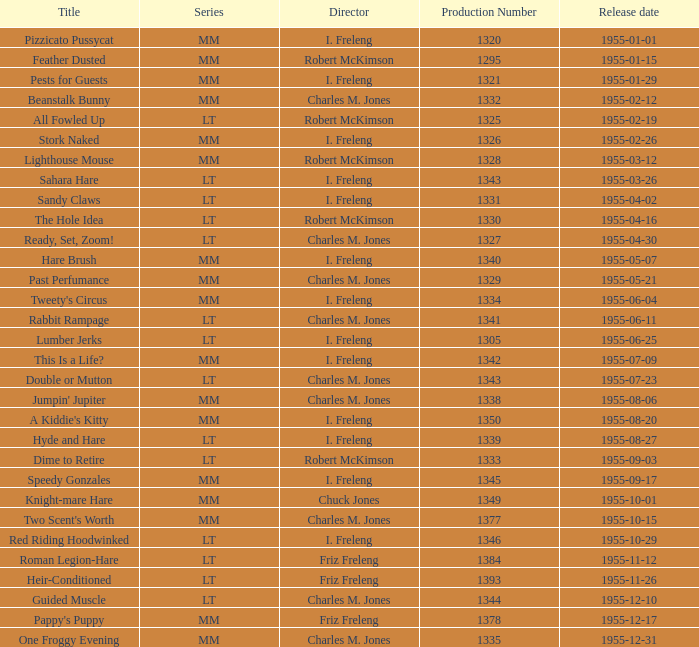What is the launch date of production number 1327? 1955-04-30. 